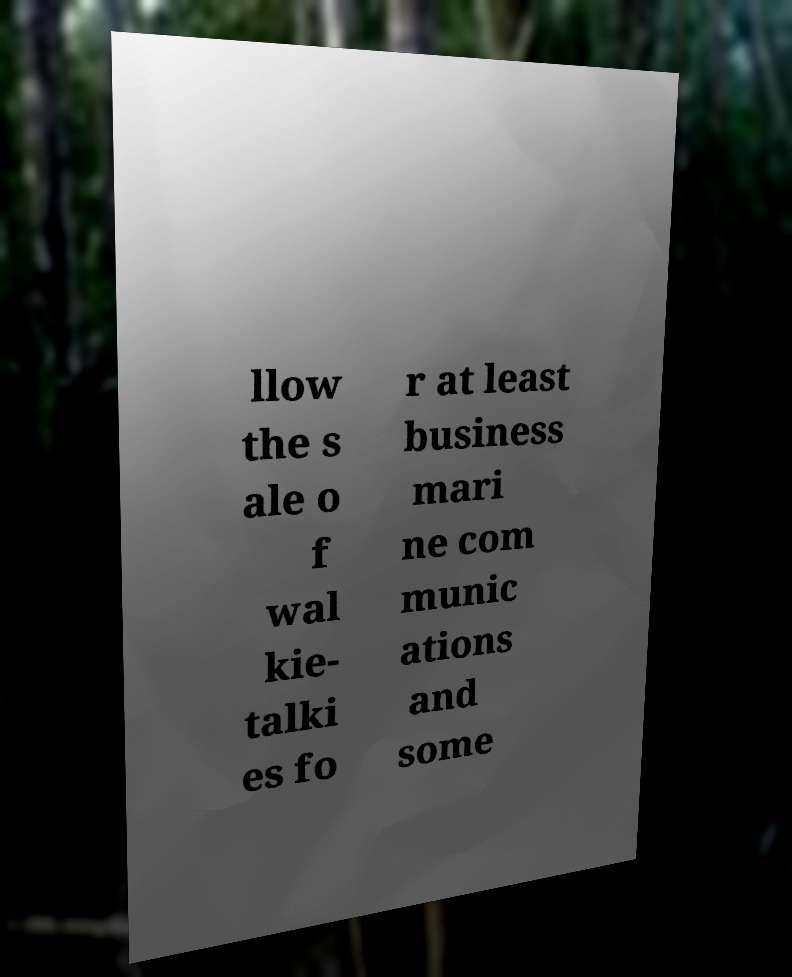I need the written content from this picture converted into text. Can you do that? llow the s ale o f wal kie- talki es fo r at least business mari ne com munic ations and some 